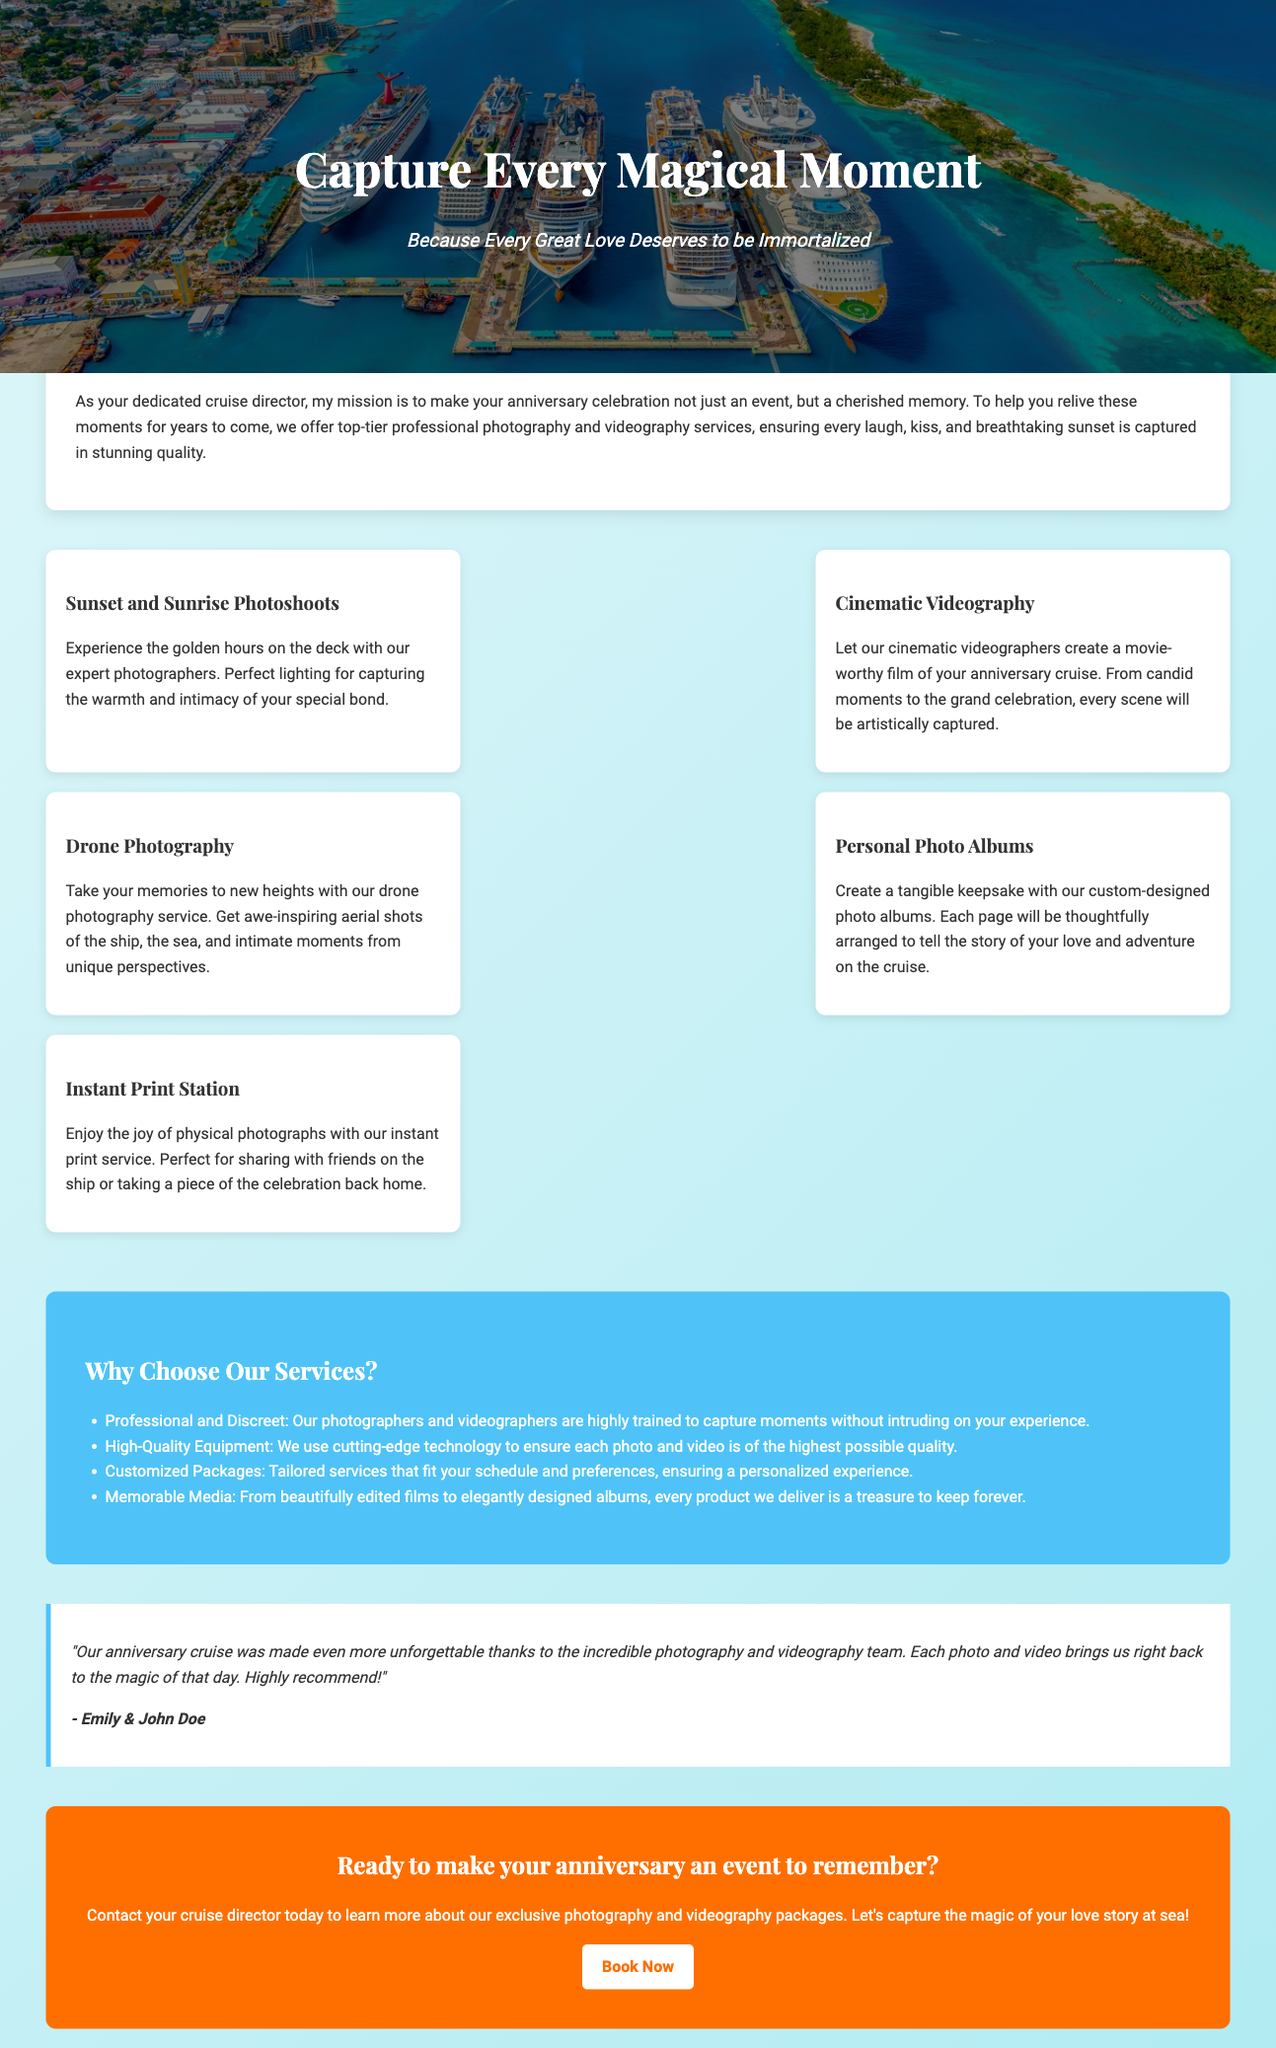What is the title of the advertisement? The title appears prominently at the top of the advertisement, clearly stating the main theme of the services offered.
Answer: Capture Every Magical Moment What services are offered during the anniversary celebration? The advertisement lists various photography and videography services that are designed to capture special moments during the cruise.
Answer: Sunset and Sunrise Photoshoots, Cinematic Videography, Drone Photography, Personal Photo Albums, Instant Print Station Who is the testimonial from? The testimonial is provided by a couple who experienced the photography and videography services, adding credibility to the advertisement.
Answer: Emily & John Doe What is the color of the call-to-action (CTA) background? The CTA background color stands out and is designed to grab the reader's attention at the end of the advertisement.
Answer: Orange What unique selling point is highlighted regarding the quality of the photos and videos? The document emphasizes the importance of utilizing high-quality equipment for capturing memorable moments during the cruise.
Answer: High-Quality Equipment What is one feature of the Cinematic Videography service? The description specifies how the service can create a film-like experience of the anniversary celebration.
Answer: Movie-worthy film How can potential clients contact the cruise director? The advertisement encourages readers to reach out through the contact option mentioned in the CTA section.
Answer: Contact your cruise director What type of photography captures both intimate moments and grand celebrations? The advertisement provides a specific service focused on capturing various important moments throughout the event.
Answer: Cinematic Videography What is offered as a tangible keepsake of the memories? The advertisement promotes a specific service aimed at providing clients with physical representations of their memories.
Answer: Custom-designed photo albums 